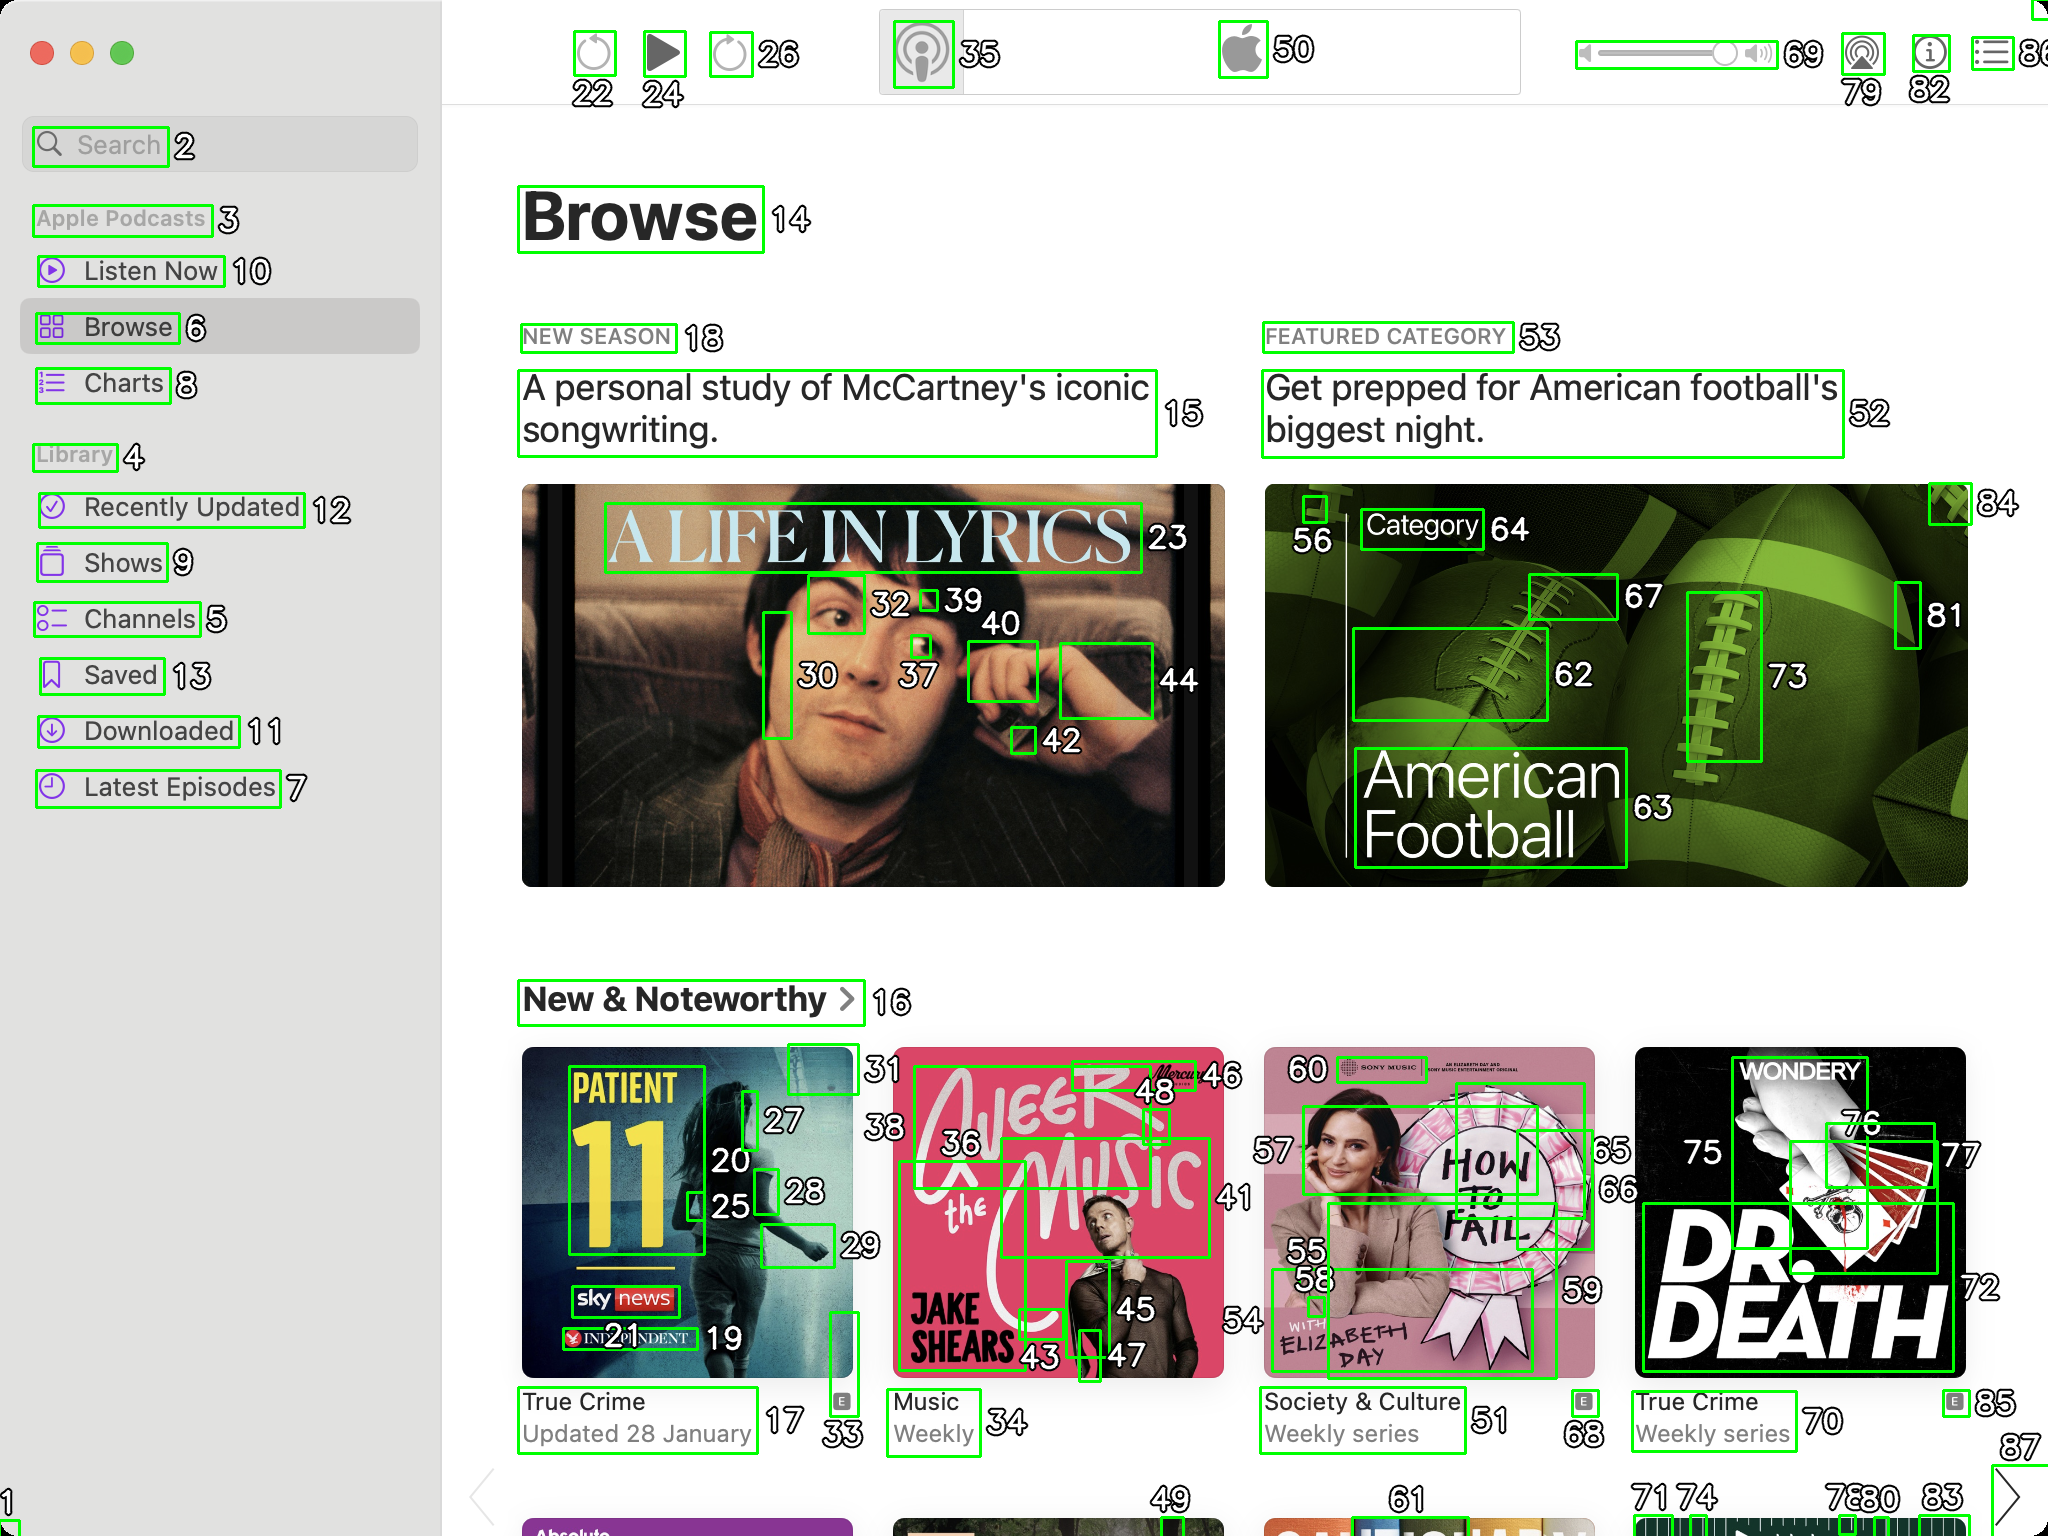You are an AI designed for image processing and segmentation analysis, particularly skilled in merging segmented regions of an image to improve accuracy and readability.

**Task Description:**
Your task is to address a user's concern with a UI screenshot of the Apple Podcasts application on MacOS. The screenshot contains multiple green boxes, each representing a UI element, with a unique white number outlined in black ranging from 1 to 88. Due to segmentation issues, some boxes that belong to the same image are divided unnaturally.

**Objective:**
Merge these segmented areas that correspond to a single UI element to create a coherent representation. The final output should be in JSON format, where each key-value pair represents the merged areas.

**Example JSON Output:**
If boxes with numbers 1, 2, and 3 should belong to the same UI element, the JSON output should be:

```json
{
    "Image A Life In Lyrics": [1, 2, 3]
}
```

**Instructions:**

- **Identify Segmented Regions:** Analyze the screenshot to identify which green boxes belong to the same UI element.
- **Merge Regions:** Group the numbers of these boxes together to represent a single UI element.
- **Output Format:** Produce the output in JSON format, with each key representing a UI element and each value being a list of the numbers of the merged boxes. If UI element contains only one box than skip that element in final result.

**Primary Objective:**
Ensure the accuracy of the merged regions based on the user's supplied image information, maintaining the integrity and structure of the UI elements in the Apple Podcasts application on MacOS. Based on the provided screenshot, I have identified the segmented regions that belong to the same UI elements and merged them accordingly. Here is the JSON output representing the merged areas:

```json
{
    "Search": [2],
    "Apple Podcasts": [3],
    "Listen Now": [10],
    "Browse": [6],
    "Charts": [8],
    "Library": [4],
    "Recently Updated": [12],
    "Shows": [9],
    "Channels": [5],
    "Saved": [13],
    "Downloaded": [11],
    "Latest Episodes": [7],
    "Browse Title": [14],
    "New Season": [18],
    "A Life In Lyrics": [15, 23, 30, 32, 37, 39, 40, 42, 44],
    "Featured Category": [53],
    "American Football": [52, 62, 63, 64, 67, 73, 81, 84],
    "New & Noteworthy": [16],
    "Patient 11": [17, 20, 25, 27, 28, 33],
    "True Crime Updated 28 January": [19],
    "A Life In Lyrics": [36, 43, 45, 46, 48],
    "Music Weekly": [35],
    "How To Fail": [55, 56, 59, 60],
    "Society & Culture Weekly Series": [51],
    "Dr. Death": [70, 72, 75, 76, 77],
    "True Crime Weekly Series": [68],
    "Wondery": [71, 74, 78, 79, 80, 82, 85]
}
```

This JSON output groups the segmented regions into coherent UI elements based on the provided screenshot. Each key represents a UI element, and each value is a list of the numbers of the merged boxes. 